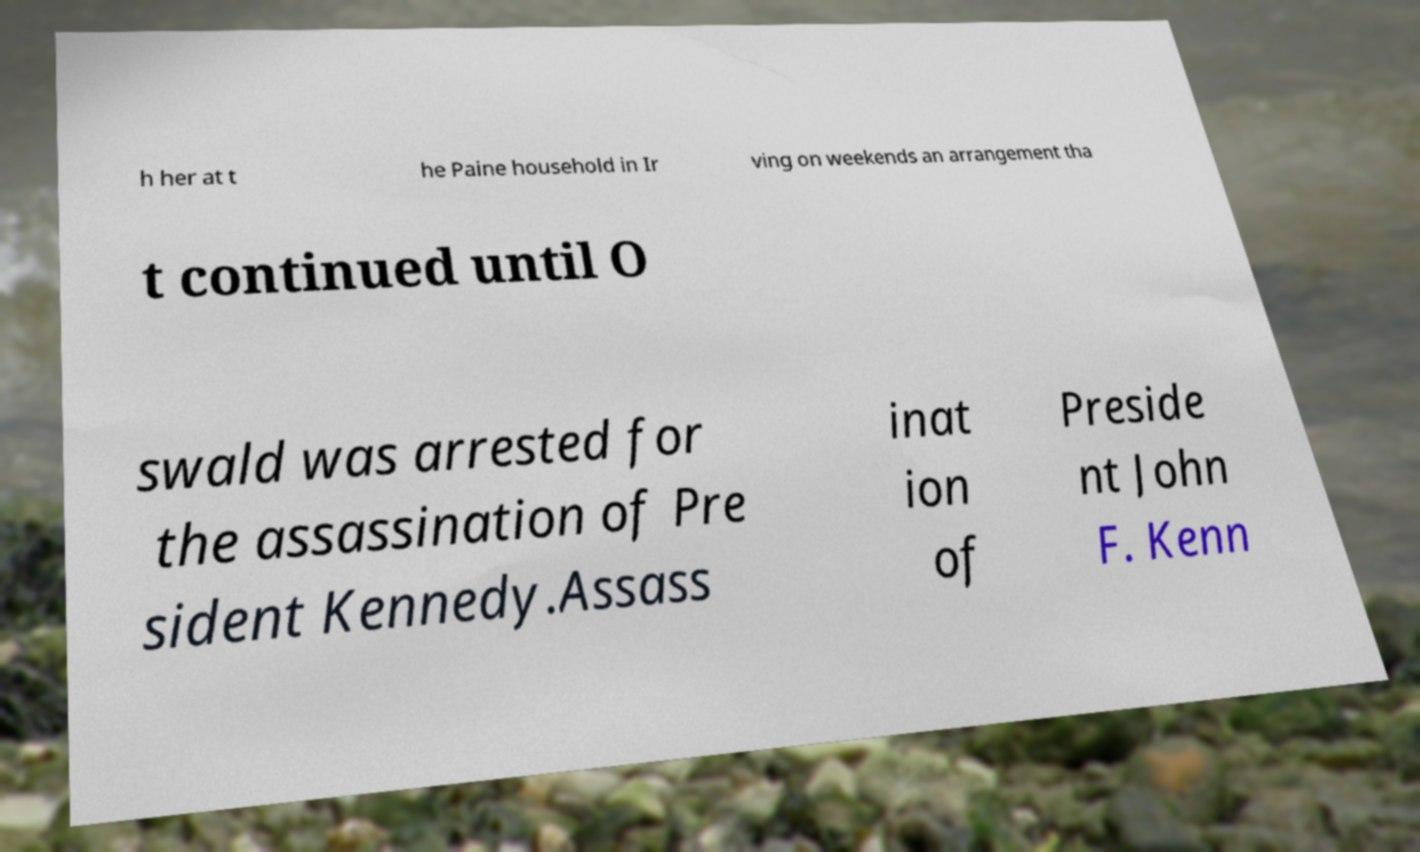For documentation purposes, I need the text within this image transcribed. Could you provide that? h her at t he Paine household in Ir ving on weekends an arrangement tha t continued until O swald was arrested for the assassination of Pre sident Kennedy.Assass inat ion of Preside nt John F. Kenn 